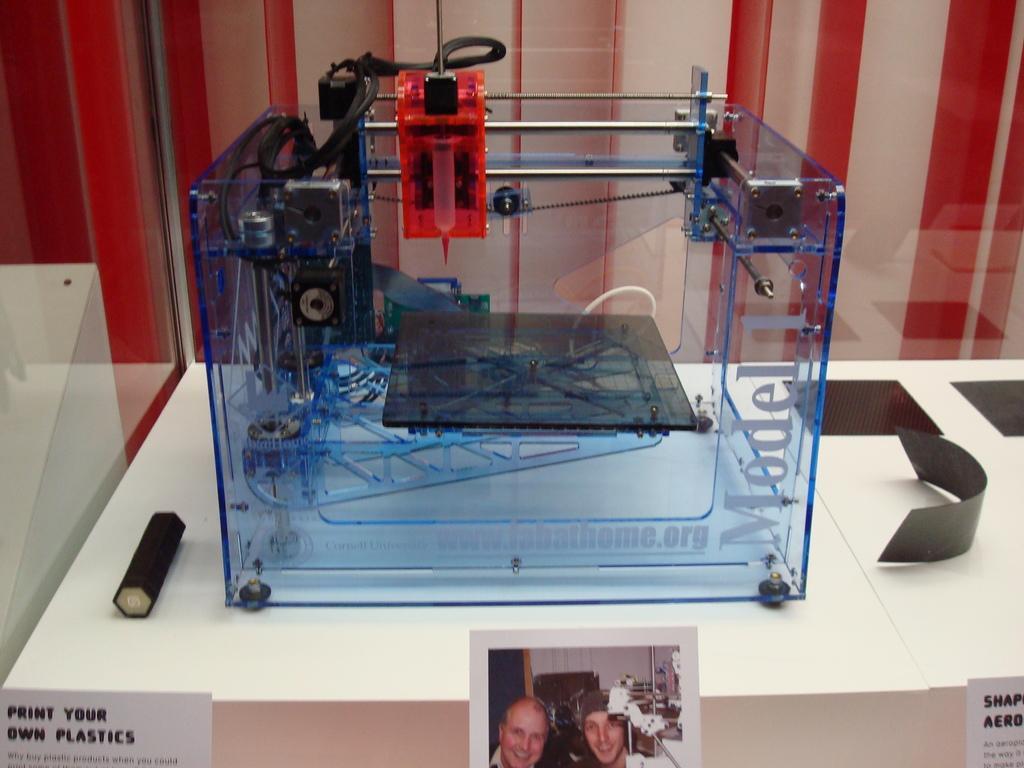Could you give a brief overview of what you see in this image? In the center of the image we can see the blue color object with the text on it and the object is placed on the white surface. At the bottom we can also see the pages with text and also the paper with images. In the background we can see the wall with red and white combination. 